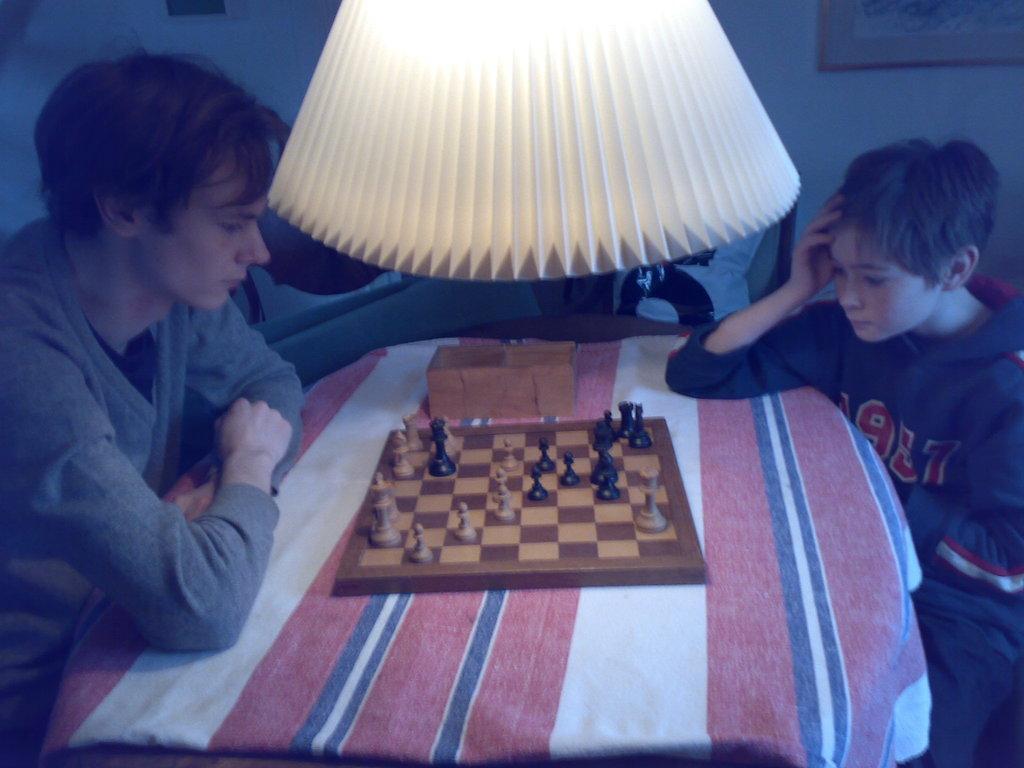Could you give a brief overview of what you see in this image? As we can see in the image there are two people sitting on chairs and there is a table. On table there is a chess board, a small box and a lamp. 